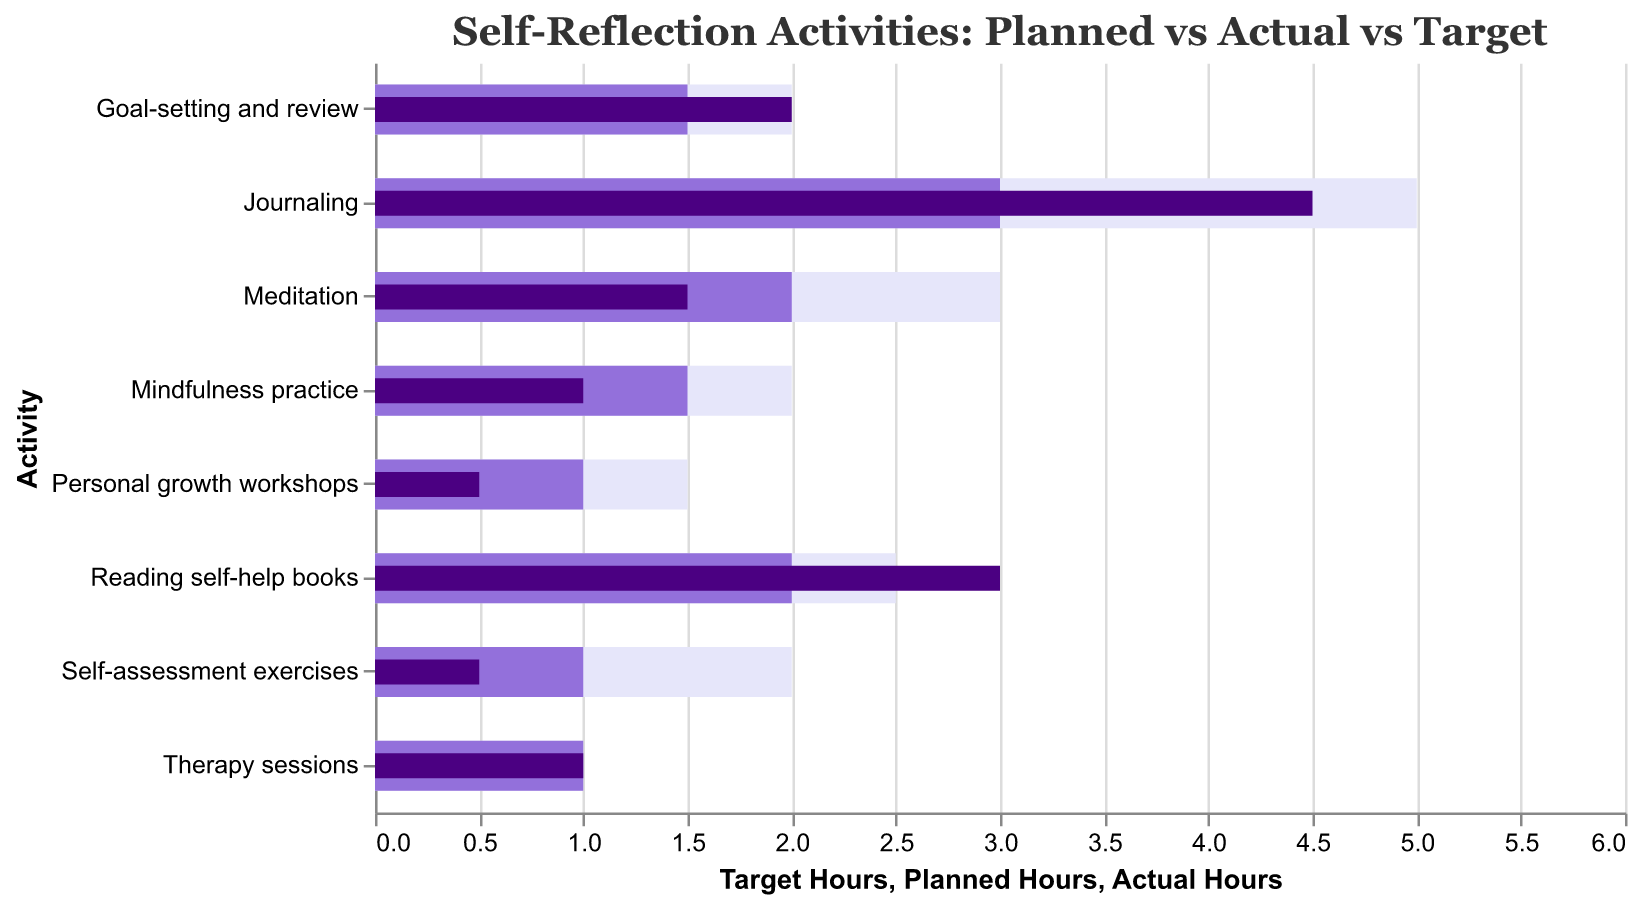Which activity has the highest actual hours spent compared to planned hours? Compare the "Actual Hours" and "Planned Hours" for each activity. The activity with the highest actual hours spent compared to planned hours is "Journaling," with 4.5 actual hours versus 3 planned hours.
Answer: Journaling How does Meditation compare to its target hours? Check the "Meditation" bar for "Target Hours," which is 3, and compare it to the "Actual Hours," which is 1.5.
Answer: 1.5 hours less What is the total planned hours for all activities? Sum up "Planned Hours" for all activities: 3 + 2 + 1 + 1.5 + 2 + 1 + 1.5 + 1 = 13
Answer: 13 hours For which activity did you exactly meet your target hours? Check if "Actual Hours" equals "Target Hours" for any activities. "Therapy sessions" meets this criteria with both being 1 hour.
Answer: Therapy sessions Which activity has the largest gap between planned hours and actual hours? Calculate the difference between "Planned Hours" and "Actual Hours" for each activity. "Self-assessment exercises" show the largest gap, where 1 planned hour is reduced to 0.5 actual hours.
Answer: Self-assessment exercises Which activity is closest to the target hours without exceeding the target? Compare the "Actual Hours" to "Target Hours" and check for the closeness without exceeding. "Mindfulness practice" is closest with 1 actual hour, without exceeding the target of 2.
Answer: Mindfulness practice How much time in total did you actually spend on all activities? Sum up "Actual Hours" for all activities: 4.5 + 1.5 + 0.5 + 1 + 3 + 1 + 2 + 0.5 = 14
Answer: 14 hours Which activity shows a perfect match between planned and actual hours? Check each activity to see where "Planned Hours" equals "Actual Hours." "Therapy sessions" is the activity where both planned and actual hours are 1.
Answer: Therapy sessions What is the difference between the actual and target hours for Reading self-help books? Compare "Actual Hours" for "Reading self-help books," which is 3, with the "Target Hours," which is 2.5. The difference is 3 - 2.5 = 0.5.
Answer: 0.5 hours Which activities fall short of their planned hours? Identify activities where "Actual Hours" is less than "Planned Hours." These activities are "Meditation," "Self-assessment exercises," "Mindfulness practice," and "Personal growth workshops."
Answer: Meditation, Self-assessment exercises, Mindfulness practice, Personal growth workshops 